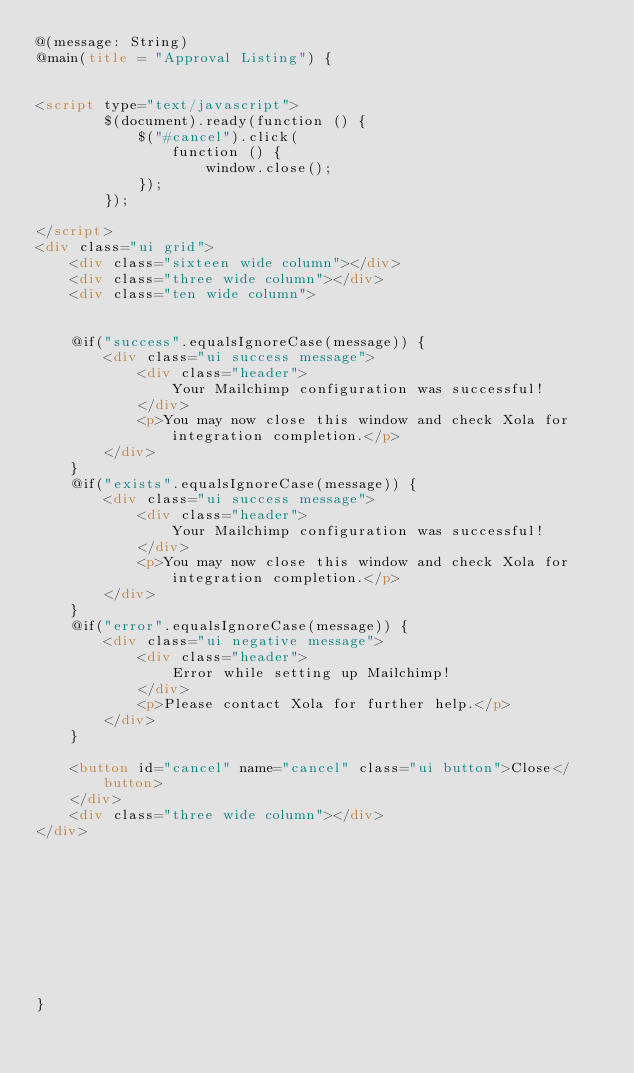Convert code to text. <code><loc_0><loc_0><loc_500><loc_500><_HTML_>@(message: String)
@main(title = "Approval Listing") {


<script type="text/javascript">
        $(document).ready(function () {
            $("#cancel").click(
                function () {
                    window.close();
            });
        });

</script>
<div class="ui grid">
    <div class="sixteen wide column"></div>
    <div class="three wide column"></div>
    <div class="ten wide column">


    @if("success".equalsIgnoreCase(message)) {
        <div class="ui success message">
            <div class="header">
                Your Mailchimp configuration was successful!
            </div>
            <p>You may now close this window and check Xola for integration completion.</p>
        </div>
    }
    @if("exists".equalsIgnoreCase(message)) {
        <div class="ui success message">
            <div class="header">
                Your Mailchimp configuration was successful!
            </div>
            <p>You may now close this window and check Xola for integration completion.</p>
        </div>
    }
    @if("error".equalsIgnoreCase(message)) {
        <div class="ui negative message">
            <div class="header">
                Error while setting up Mailchimp!
            </div>
            <p>Please contact Xola for further help.</p>
        </div>
    }

    <button id="cancel" name="cancel" class="ui button">Close</button>
    </div>
    <div class="three wide column"></div>
</div>










}</code> 